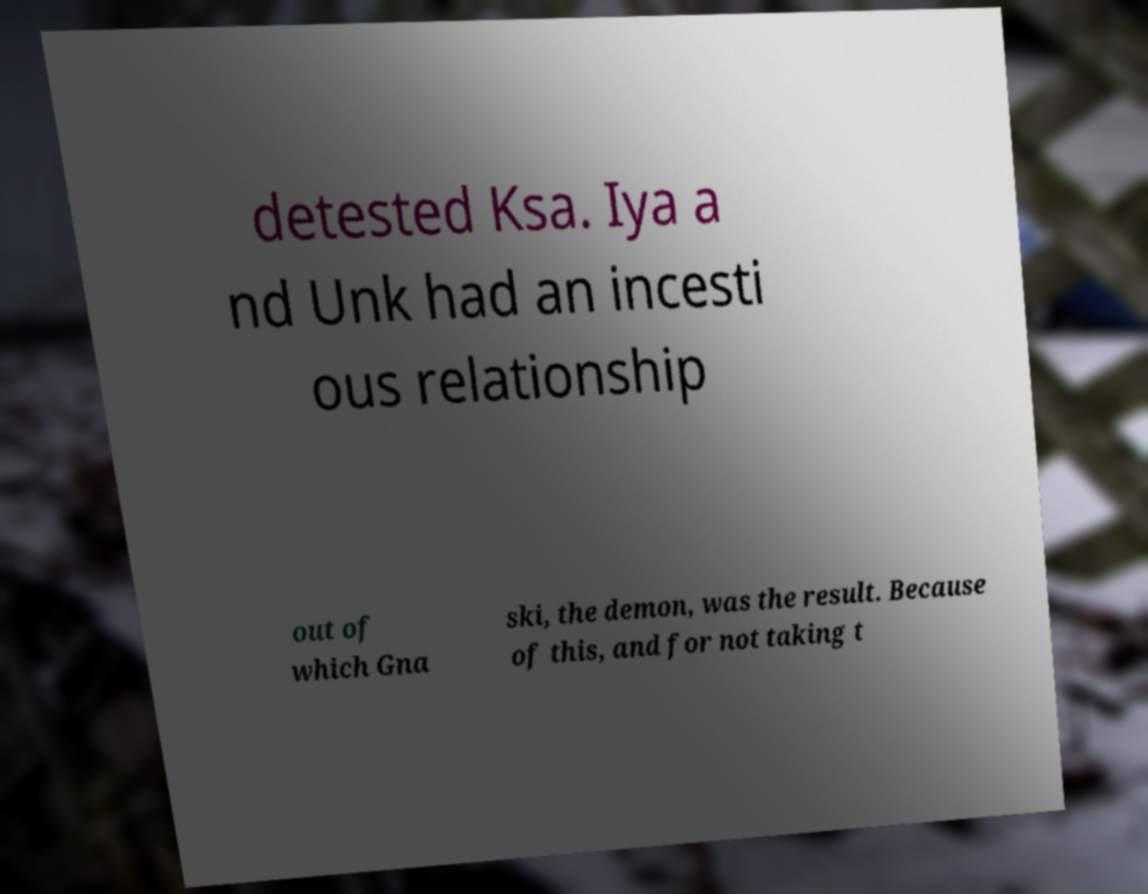I need the written content from this picture converted into text. Can you do that? detested Ksa. Iya a nd Unk had an incesti ous relationship out of which Gna ski, the demon, was the result. Because of this, and for not taking t 